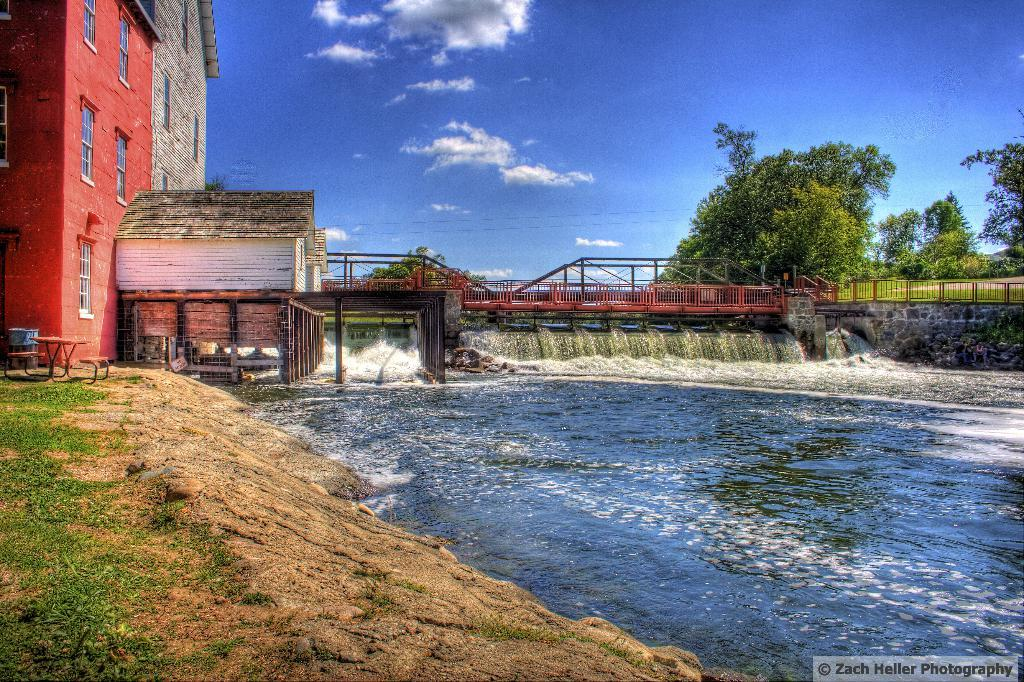What is one of the natural elements present in the image? There is water in the image. What type of terrain can be seen in the image? There is grass in the image. What man-made object is present in the image? There is a table in the image. What musical instrument is visible in the image? There is a drum in the image. What type of structure is present in the image? There is a bridge in the image. What type of building is present in the image? There is a house in the image. What type of barrier is present in the image? There is a fence in the image. What type of vegetation is present in the image? There are trees in the image. What type of wall is present in the image? There is a stone wall in the image. How would you describe the sky in the image? The sky is blue with clouds in the background. What type of prose is being recited by the trees in the image? There is no prose being recited by the trees in the image, as trees do not have the ability to recite prose. What type of border is present between the grass and the water in the image? There is no specific border between the grass and the water in the image; the transition is natural. What type of jewelry is being worn by the stone wall in the image? There is no jewelry present in the image, and the stone wall is an inanimate object that cannot wear jewelry. 